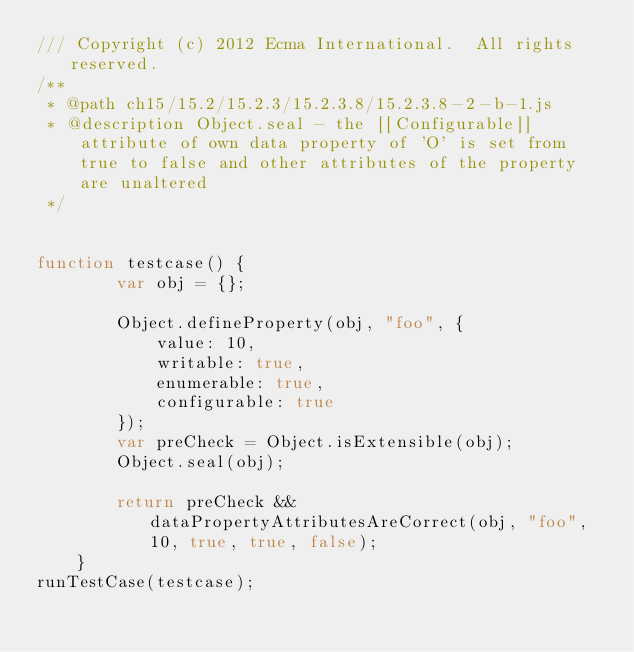Convert code to text. <code><loc_0><loc_0><loc_500><loc_500><_JavaScript_>/// Copyright (c) 2012 Ecma International.  All rights reserved. 
/**
 * @path ch15/15.2/15.2.3/15.2.3.8/15.2.3.8-2-b-1.js
 * @description Object.seal - the [[Configurable]] attribute of own data property of 'O' is set from true to false and other attributes of the property are unaltered
 */


function testcase() {
        var obj = {};

        Object.defineProperty(obj, "foo", {
            value: 10,
            writable: true,
            enumerable: true,
            configurable: true
        });
        var preCheck = Object.isExtensible(obj);
        Object.seal(obj);

        return preCheck && dataPropertyAttributesAreCorrect(obj, "foo", 10, true, true, false);
    }
runTestCase(testcase);
</code> 